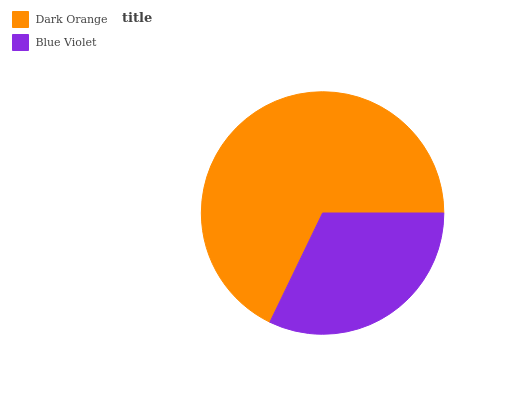Is Blue Violet the minimum?
Answer yes or no. Yes. Is Dark Orange the maximum?
Answer yes or no. Yes. Is Blue Violet the maximum?
Answer yes or no. No. Is Dark Orange greater than Blue Violet?
Answer yes or no. Yes. Is Blue Violet less than Dark Orange?
Answer yes or no. Yes. Is Blue Violet greater than Dark Orange?
Answer yes or no. No. Is Dark Orange less than Blue Violet?
Answer yes or no. No. Is Dark Orange the high median?
Answer yes or no. Yes. Is Blue Violet the low median?
Answer yes or no. Yes. Is Blue Violet the high median?
Answer yes or no. No. Is Dark Orange the low median?
Answer yes or no. No. 